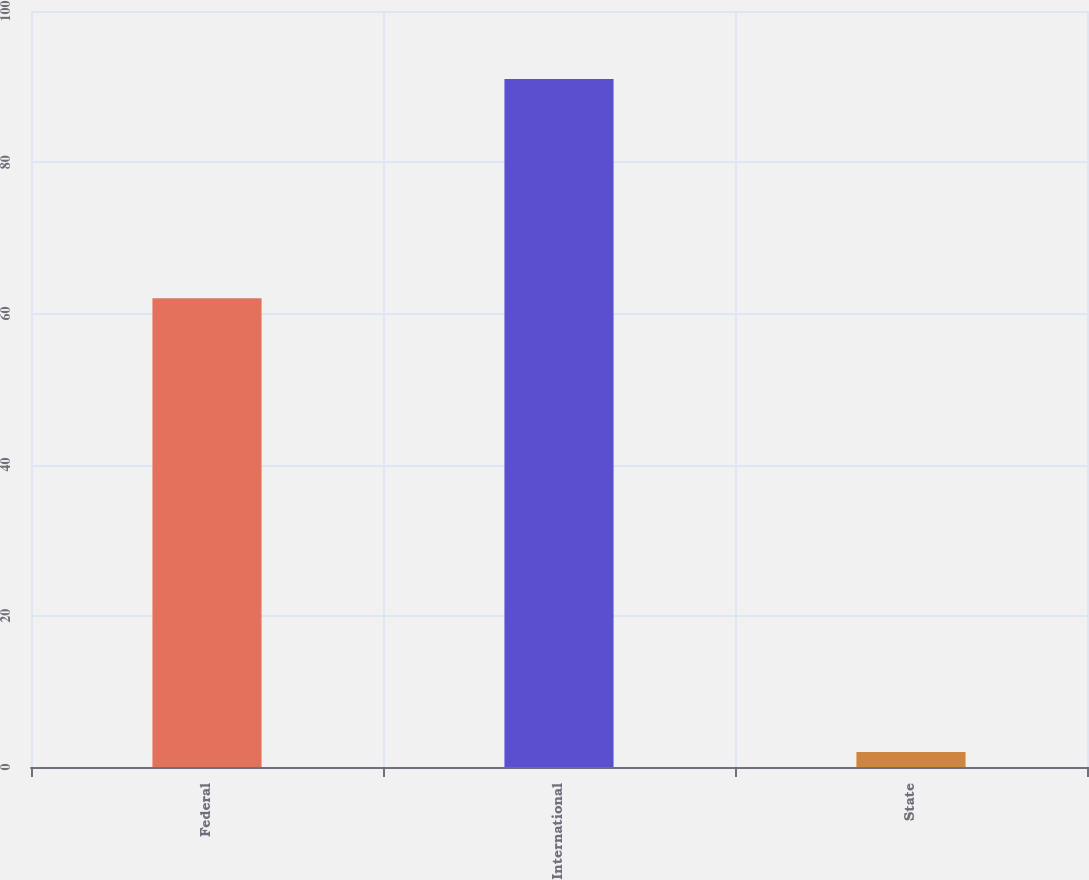Convert chart. <chart><loc_0><loc_0><loc_500><loc_500><bar_chart><fcel>Federal<fcel>International<fcel>State<nl><fcel>62<fcel>91<fcel>2<nl></chart> 